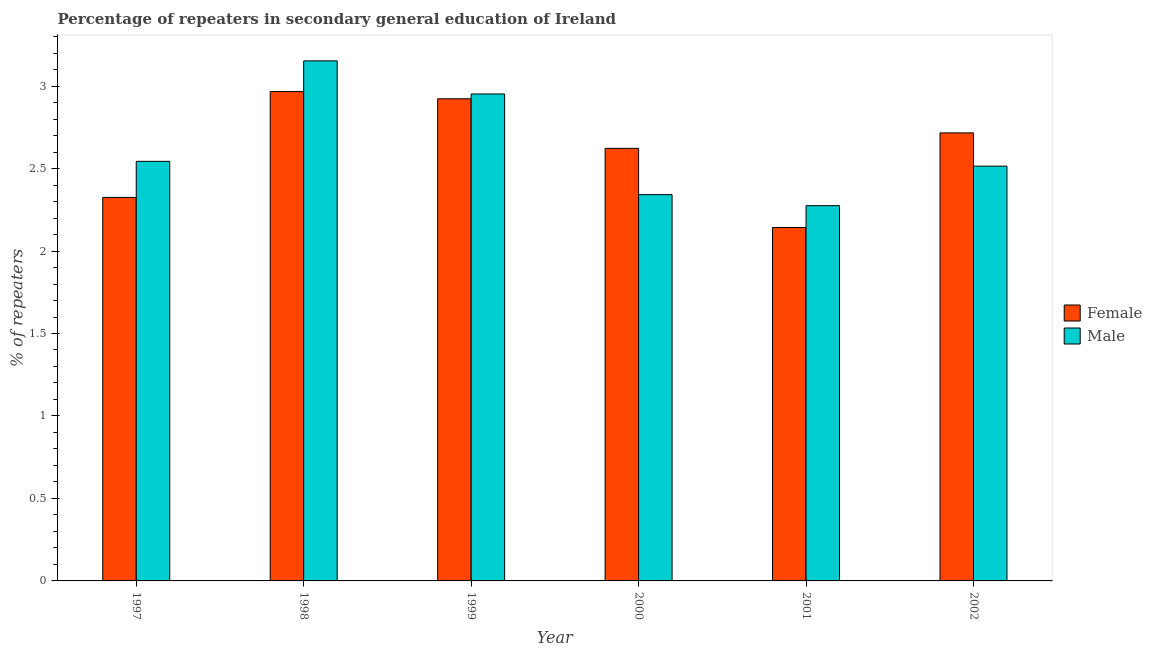How many different coloured bars are there?
Your response must be concise. 2. How many groups of bars are there?
Your answer should be compact. 6. Are the number of bars per tick equal to the number of legend labels?
Make the answer very short. Yes. How many bars are there on the 2nd tick from the left?
Give a very brief answer. 2. What is the label of the 1st group of bars from the left?
Give a very brief answer. 1997. In how many cases, is the number of bars for a given year not equal to the number of legend labels?
Keep it short and to the point. 0. What is the percentage of female repeaters in 1997?
Your answer should be very brief. 2.32. Across all years, what is the maximum percentage of female repeaters?
Make the answer very short. 2.97. Across all years, what is the minimum percentage of male repeaters?
Ensure brevity in your answer.  2.27. In which year was the percentage of female repeaters maximum?
Ensure brevity in your answer.  1998. In which year was the percentage of female repeaters minimum?
Your response must be concise. 2001. What is the total percentage of male repeaters in the graph?
Offer a terse response. 15.78. What is the difference between the percentage of male repeaters in 1998 and that in 2001?
Your answer should be very brief. 0.88. What is the difference between the percentage of male repeaters in 1998 and the percentage of female repeaters in 2000?
Provide a short and direct response. 0.81. What is the average percentage of female repeaters per year?
Provide a short and direct response. 2.62. In the year 1999, what is the difference between the percentage of male repeaters and percentage of female repeaters?
Your answer should be compact. 0. What is the ratio of the percentage of male repeaters in 1997 to that in 2002?
Make the answer very short. 1.01. Is the difference between the percentage of female repeaters in 2000 and 2002 greater than the difference between the percentage of male repeaters in 2000 and 2002?
Provide a succinct answer. No. What is the difference between the highest and the second highest percentage of male repeaters?
Make the answer very short. 0.2. What is the difference between the highest and the lowest percentage of male repeaters?
Offer a terse response. 0.88. In how many years, is the percentage of male repeaters greater than the average percentage of male repeaters taken over all years?
Give a very brief answer. 2. Are all the bars in the graph horizontal?
Offer a very short reply. No. How many years are there in the graph?
Provide a succinct answer. 6. Are the values on the major ticks of Y-axis written in scientific E-notation?
Provide a short and direct response. No. Does the graph contain any zero values?
Your answer should be very brief. No. How many legend labels are there?
Offer a terse response. 2. What is the title of the graph?
Keep it short and to the point. Percentage of repeaters in secondary general education of Ireland. Does "Commercial service imports" appear as one of the legend labels in the graph?
Your response must be concise. No. What is the label or title of the Y-axis?
Your answer should be compact. % of repeaters. What is the % of repeaters in Female in 1997?
Offer a terse response. 2.32. What is the % of repeaters of Male in 1997?
Make the answer very short. 2.54. What is the % of repeaters of Female in 1998?
Your answer should be very brief. 2.97. What is the % of repeaters in Male in 1998?
Provide a short and direct response. 3.15. What is the % of repeaters in Female in 1999?
Offer a terse response. 2.92. What is the % of repeaters in Male in 1999?
Provide a succinct answer. 2.95. What is the % of repeaters in Female in 2000?
Your answer should be compact. 2.62. What is the % of repeaters of Male in 2000?
Your response must be concise. 2.34. What is the % of repeaters of Female in 2001?
Your answer should be compact. 2.14. What is the % of repeaters of Male in 2001?
Make the answer very short. 2.27. What is the % of repeaters in Female in 2002?
Offer a terse response. 2.72. What is the % of repeaters in Male in 2002?
Your response must be concise. 2.51. Across all years, what is the maximum % of repeaters in Female?
Your answer should be compact. 2.97. Across all years, what is the maximum % of repeaters of Male?
Give a very brief answer. 3.15. Across all years, what is the minimum % of repeaters in Female?
Provide a succinct answer. 2.14. Across all years, what is the minimum % of repeaters of Male?
Give a very brief answer. 2.27. What is the total % of repeaters of Female in the graph?
Offer a terse response. 15.7. What is the total % of repeaters in Male in the graph?
Provide a short and direct response. 15.78. What is the difference between the % of repeaters of Female in 1997 and that in 1998?
Ensure brevity in your answer.  -0.64. What is the difference between the % of repeaters of Male in 1997 and that in 1998?
Offer a very short reply. -0.61. What is the difference between the % of repeaters of Female in 1997 and that in 1999?
Provide a succinct answer. -0.6. What is the difference between the % of repeaters of Male in 1997 and that in 1999?
Your response must be concise. -0.41. What is the difference between the % of repeaters of Female in 1997 and that in 2000?
Keep it short and to the point. -0.3. What is the difference between the % of repeaters of Male in 1997 and that in 2000?
Offer a terse response. 0.2. What is the difference between the % of repeaters in Female in 1997 and that in 2001?
Ensure brevity in your answer.  0.18. What is the difference between the % of repeaters in Male in 1997 and that in 2001?
Your response must be concise. 0.27. What is the difference between the % of repeaters in Female in 1997 and that in 2002?
Make the answer very short. -0.39. What is the difference between the % of repeaters in Male in 1997 and that in 2002?
Your response must be concise. 0.03. What is the difference between the % of repeaters of Female in 1998 and that in 1999?
Your response must be concise. 0.04. What is the difference between the % of repeaters in Male in 1998 and that in 1999?
Give a very brief answer. 0.2. What is the difference between the % of repeaters of Female in 1998 and that in 2000?
Ensure brevity in your answer.  0.34. What is the difference between the % of repeaters in Male in 1998 and that in 2000?
Offer a very short reply. 0.81. What is the difference between the % of repeaters in Female in 1998 and that in 2001?
Offer a very short reply. 0.82. What is the difference between the % of repeaters in Male in 1998 and that in 2001?
Offer a terse response. 0.88. What is the difference between the % of repeaters in Female in 1998 and that in 2002?
Make the answer very short. 0.25. What is the difference between the % of repeaters of Male in 1998 and that in 2002?
Keep it short and to the point. 0.64. What is the difference between the % of repeaters in Female in 1999 and that in 2000?
Make the answer very short. 0.3. What is the difference between the % of repeaters of Male in 1999 and that in 2000?
Provide a short and direct response. 0.61. What is the difference between the % of repeaters in Female in 1999 and that in 2001?
Your answer should be compact. 0.78. What is the difference between the % of repeaters in Male in 1999 and that in 2001?
Your answer should be compact. 0.68. What is the difference between the % of repeaters in Female in 1999 and that in 2002?
Give a very brief answer. 0.21. What is the difference between the % of repeaters in Male in 1999 and that in 2002?
Your answer should be compact. 0.44. What is the difference between the % of repeaters in Female in 2000 and that in 2001?
Your response must be concise. 0.48. What is the difference between the % of repeaters in Male in 2000 and that in 2001?
Your answer should be compact. 0.07. What is the difference between the % of repeaters of Female in 2000 and that in 2002?
Ensure brevity in your answer.  -0.09. What is the difference between the % of repeaters of Male in 2000 and that in 2002?
Give a very brief answer. -0.17. What is the difference between the % of repeaters of Female in 2001 and that in 2002?
Your answer should be very brief. -0.57. What is the difference between the % of repeaters of Male in 2001 and that in 2002?
Your answer should be compact. -0.24. What is the difference between the % of repeaters in Female in 1997 and the % of repeaters in Male in 1998?
Your answer should be very brief. -0.83. What is the difference between the % of repeaters in Female in 1997 and the % of repeaters in Male in 1999?
Your response must be concise. -0.63. What is the difference between the % of repeaters of Female in 1997 and the % of repeaters of Male in 2000?
Provide a short and direct response. -0.02. What is the difference between the % of repeaters in Female in 1997 and the % of repeaters in Male in 2001?
Your answer should be compact. 0.05. What is the difference between the % of repeaters in Female in 1997 and the % of repeaters in Male in 2002?
Your response must be concise. -0.19. What is the difference between the % of repeaters in Female in 1998 and the % of repeaters in Male in 1999?
Give a very brief answer. 0.01. What is the difference between the % of repeaters in Female in 1998 and the % of repeaters in Male in 2000?
Keep it short and to the point. 0.62. What is the difference between the % of repeaters of Female in 1998 and the % of repeaters of Male in 2001?
Ensure brevity in your answer.  0.69. What is the difference between the % of repeaters of Female in 1998 and the % of repeaters of Male in 2002?
Your response must be concise. 0.45. What is the difference between the % of repeaters in Female in 1999 and the % of repeaters in Male in 2000?
Your response must be concise. 0.58. What is the difference between the % of repeaters in Female in 1999 and the % of repeaters in Male in 2001?
Ensure brevity in your answer.  0.65. What is the difference between the % of repeaters of Female in 1999 and the % of repeaters of Male in 2002?
Your answer should be very brief. 0.41. What is the difference between the % of repeaters in Female in 2000 and the % of repeaters in Male in 2001?
Provide a succinct answer. 0.35. What is the difference between the % of repeaters of Female in 2000 and the % of repeaters of Male in 2002?
Provide a succinct answer. 0.11. What is the difference between the % of repeaters of Female in 2001 and the % of repeaters of Male in 2002?
Provide a short and direct response. -0.37. What is the average % of repeaters of Female per year?
Give a very brief answer. 2.62. What is the average % of repeaters of Male per year?
Your response must be concise. 2.63. In the year 1997, what is the difference between the % of repeaters in Female and % of repeaters in Male?
Ensure brevity in your answer.  -0.22. In the year 1998, what is the difference between the % of repeaters in Female and % of repeaters in Male?
Ensure brevity in your answer.  -0.19. In the year 1999, what is the difference between the % of repeaters in Female and % of repeaters in Male?
Make the answer very short. -0.03. In the year 2000, what is the difference between the % of repeaters of Female and % of repeaters of Male?
Offer a very short reply. 0.28. In the year 2001, what is the difference between the % of repeaters in Female and % of repeaters in Male?
Provide a succinct answer. -0.13. In the year 2002, what is the difference between the % of repeaters in Female and % of repeaters in Male?
Your answer should be compact. 0.2. What is the ratio of the % of repeaters of Female in 1997 to that in 1998?
Your answer should be very brief. 0.78. What is the ratio of the % of repeaters in Male in 1997 to that in 1998?
Your answer should be very brief. 0.81. What is the ratio of the % of repeaters of Female in 1997 to that in 1999?
Give a very brief answer. 0.8. What is the ratio of the % of repeaters of Male in 1997 to that in 1999?
Make the answer very short. 0.86. What is the ratio of the % of repeaters in Female in 1997 to that in 2000?
Make the answer very short. 0.89. What is the ratio of the % of repeaters in Male in 1997 to that in 2000?
Provide a succinct answer. 1.09. What is the ratio of the % of repeaters of Female in 1997 to that in 2001?
Your answer should be compact. 1.08. What is the ratio of the % of repeaters of Male in 1997 to that in 2001?
Give a very brief answer. 1.12. What is the ratio of the % of repeaters of Female in 1997 to that in 2002?
Ensure brevity in your answer.  0.86. What is the ratio of the % of repeaters of Male in 1997 to that in 2002?
Offer a terse response. 1.01. What is the ratio of the % of repeaters in Male in 1998 to that in 1999?
Keep it short and to the point. 1.07. What is the ratio of the % of repeaters in Female in 1998 to that in 2000?
Keep it short and to the point. 1.13. What is the ratio of the % of repeaters in Male in 1998 to that in 2000?
Offer a very short reply. 1.35. What is the ratio of the % of repeaters of Female in 1998 to that in 2001?
Provide a short and direct response. 1.38. What is the ratio of the % of repeaters in Male in 1998 to that in 2001?
Your answer should be compact. 1.39. What is the ratio of the % of repeaters of Female in 1998 to that in 2002?
Your answer should be very brief. 1.09. What is the ratio of the % of repeaters in Male in 1998 to that in 2002?
Provide a succinct answer. 1.25. What is the ratio of the % of repeaters of Female in 1999 to that in 2000?
Give a very brief answer. 1.11. What is the ratio of the % of repeaters of Male in 1999 to that in 2000?
Your answer should be very brief. 1.26. What is the ratio of the % of repeaters in Female in 1999 to that in 2001?
Offer a terse response. 1.36. What is the ratio of the % of repeaters of Male in 1999 to that in 2001?
Make the answer very short. 1.3. What is the ratio of the % of repeaters of Female in 1999 to that in 2002?
Provide a short and direct response. 1.08. What is the ratio of the % of repeaters of Male in 1999 to that in 2002?
Make the answer very short. 1.17. What is the ratio of the % of repeaters in Female in 2000 to that in 2001?
Your answer should be very brief. 1.22. What is the ratio of the % of repeaters of Male in 2000 to that in 2001?
Ensure brevity in your answer.  1.03. What is the ratio of the % of repeaters in Female in 2000 to that in 2002?
Give a very brief answer. 0.97. What is the ratio of the % of repeaters of Male in 2000 to that in 2002?
Provide a succinct answer. 0.93. What is the ratio of the % of repeaters of Female in 2001 to that in 2002?
Your response must be concise. 0.79. What is the ratio of the % of repeaters of Male in 2001 to that in 2002?
Offer a very short reply. 0.9. What is the difference between the highest and the second highest % of repeaters in Female?
Keep it short and to the point. 0.04. What is the difference between the highest and the second highest % of repeaters in Male?
Offer a terse response. 0.2. What is the difference between the highest and the lowest % of repeaters of Female?
Give a very brief answer. 0.82. What is the difference between the highest and the lowest % of repeaters of Male?
Provide a succinct answer. 0.88. 